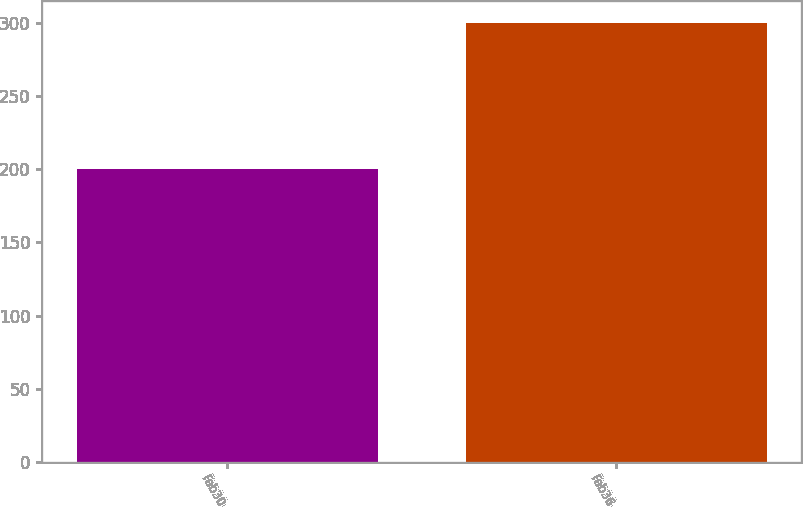Convert chart to OTSL. <chart><loc_0><loc_0><loc_500><loc_500><bar_chart><fcel>Fab30<fcel>Fab36<nl><fcel>200<fcel>300<nl></chart> 